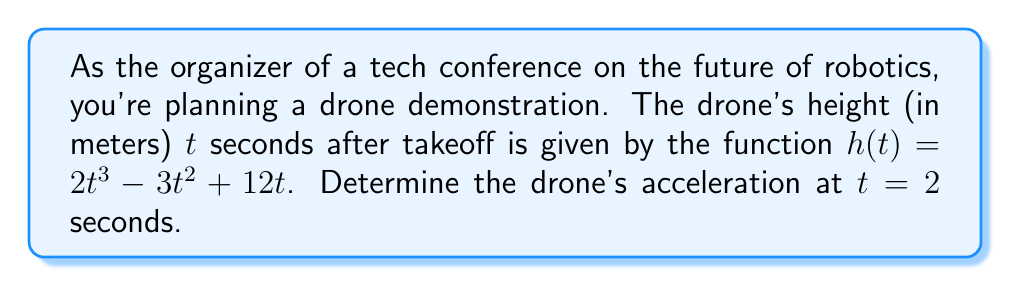Give your solution to this math problem. To find the acceleration of the drone, we need to calculate the second derivative of the height function h(t).

Step 1: Find the first derivative (velocity function)
The first derivative represents the velocity of the drone.
$$h'(t) = \frac{d}{dt}(2t^3 - 3t^2 + 12t)$$
$$h'(t) = 6t^2 - 6t + 12$$

Step 2: Find the second derivative (acceleration function)
The second derivative represents the acceleration of the drone.
$$h''(t) = \frac{d}{dt}(6t^2 - 6t + 12)$$
$$h''(t) = 12t - 6$$

Step 3: Calculate the acceleration at t = 2 seconds
Substitute t = 2 into the acceleration function:
$$h''(2) = 12(2) - 6$$
$$h''(2) = 24 - 6 = 18$$

Therefore, the acceleration of the drone at t = 2 seconds is 18 m/s².
Answer: 18 m/s² 